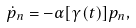<formula> <loc_0><loc_0><loc_500><loc_500>\dot { p } _ { n } = - \alpha [ \gamma ( t ) ] p _ { n } ,</formula> 